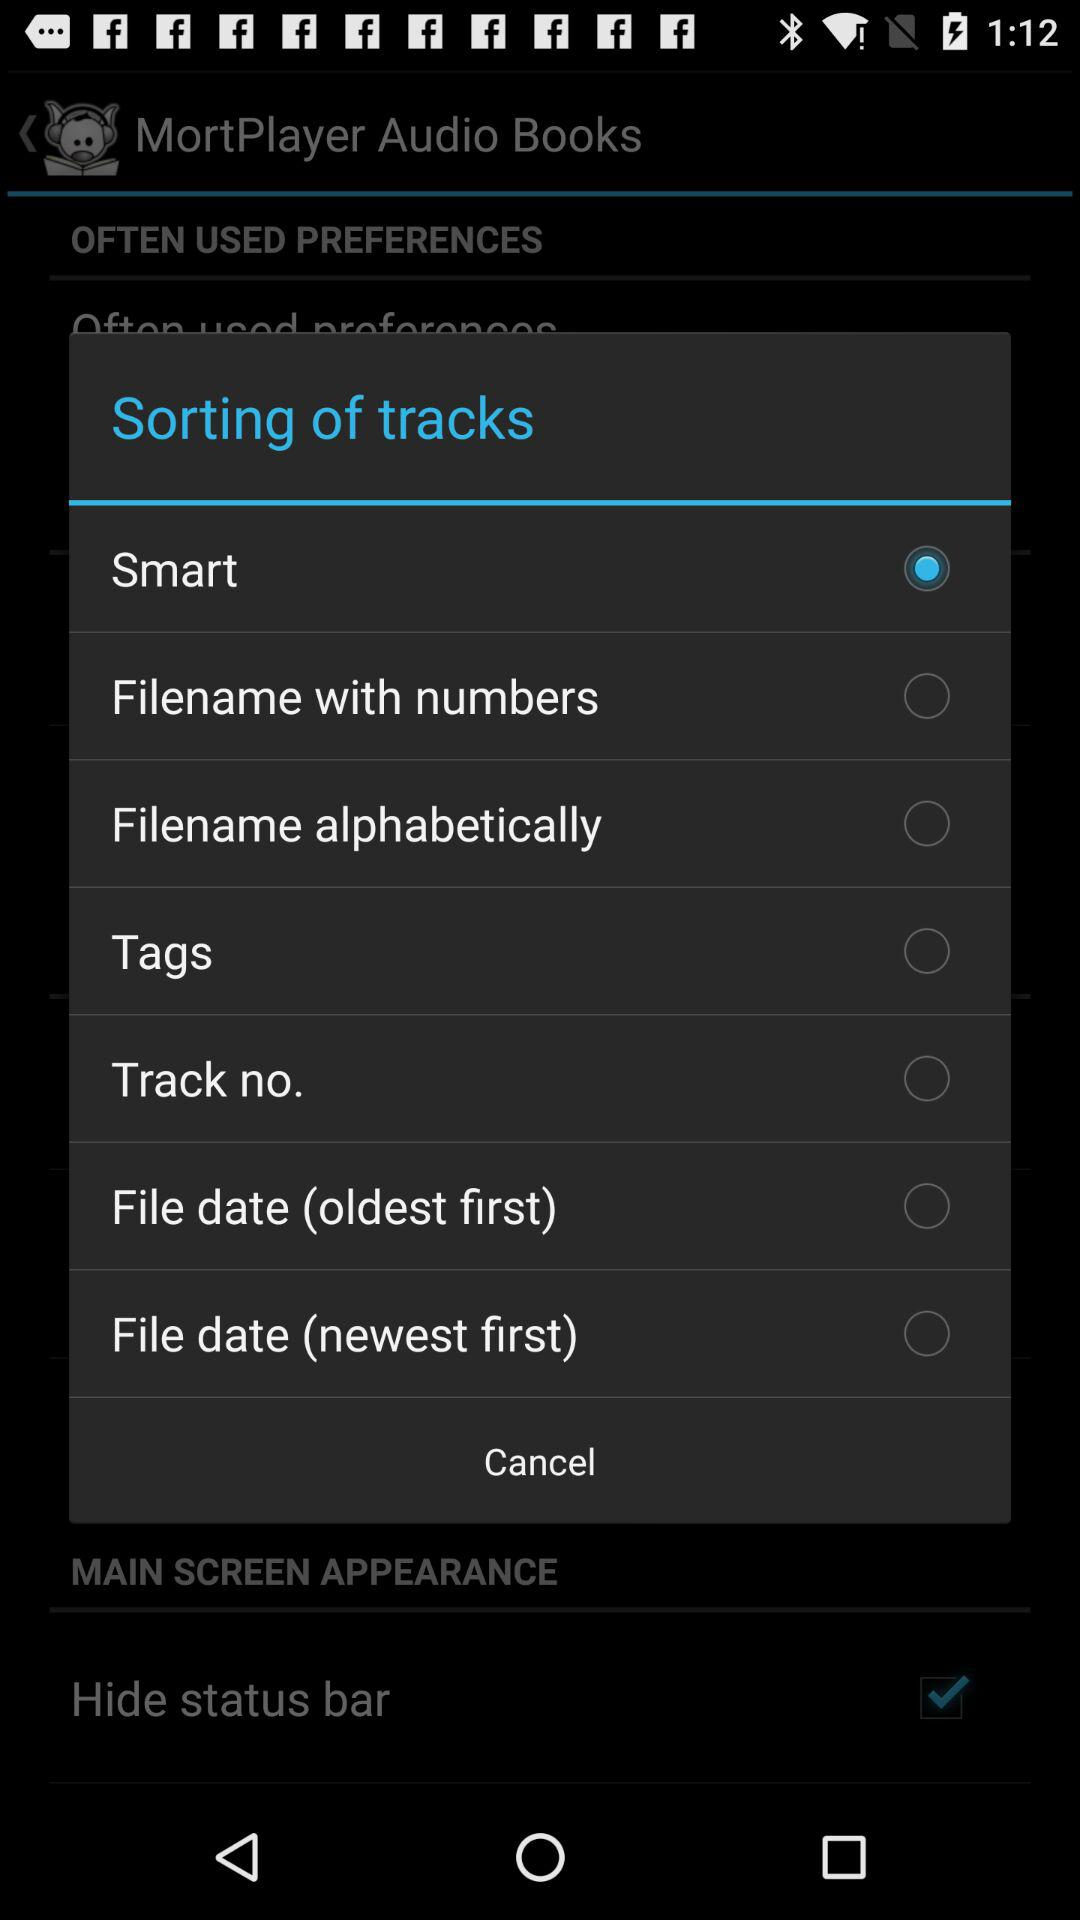Is "Tags" selected or not? "Tags" is not selected. 